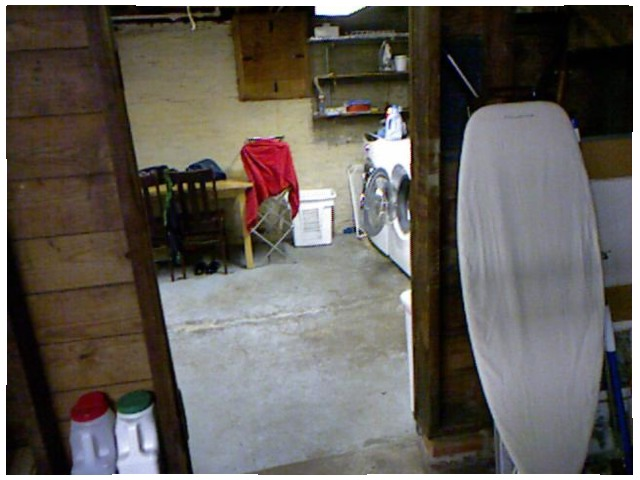<image>
Is the hinge on the door? Yes. Looking at the image, I can see the hinge is positioned on top of the door, with the door providing support. 